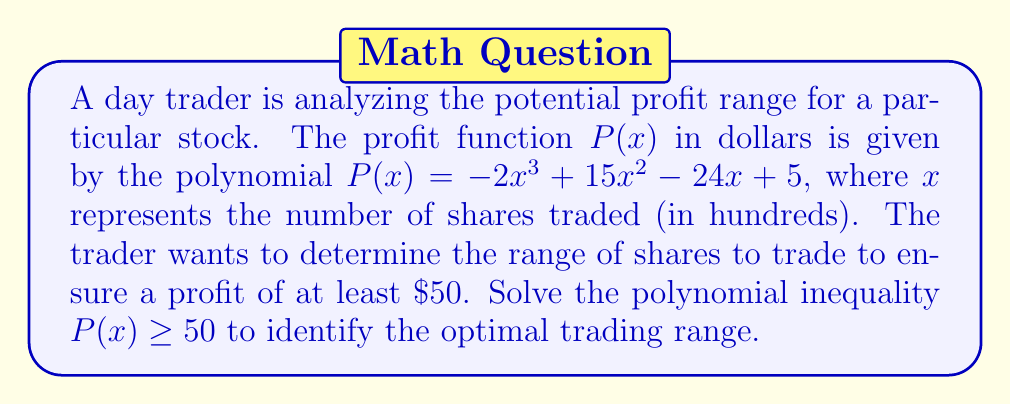Help me with this question. To solve this problem, we need to follow these steps:

1) First, we set up the inequality:
   $$-2x^3 + 15x^2 - 24x + 5 \geq 50$$

2) Subtract 50 from both sides:
   $$-2x^3 + 15x^2 - 24x - 45 \geq 0$$

3) Let's call the left side of the inequality $f(x)$. So we need to solve $f(x) \geq 0$.

4) To find the roots of $f(x)$, we can factor it:
   $$f(x) = -2x^3 + 15x^2 - 24x - 45$$
   $$= -(2x^3 - 15x^2 + 24x + 45)$$
   $$= -(x + 3)(2x^2 - 21x + 15)$$
   $$= -(x + 3)(2x - 3)(x - 9)$$

5) The roots of $f(x)$ are $x = -3$, $x = \frac{3}{2}$, and $x = 9$.

6) Now we need to determine where $f(x) \geq 0$. Since the leading coefficient is negative, $f(x)$ will be positive between its first and second roots, and after its third root.

7) However, since $x$ represents the number of shares traded, it can't be negative. So we only consider the non-negative range.

8) Therefore, the solution to the inequality is:
   $$\frac{3}{2} \leq x \leq 9 \text{ or } x \geq 9$$

9) Converting back to hundreds of shares:
   $$150 \leq x \leq 900 \text{ or } x \geq 900$$
Answer: The optimal trading range for a profit of at least $\$50$ is to trade 150 shares or more. Specifically, trading between 150 and 900 shares (inclusive) or 900 or more shares will yield a profit of at least $\$50$. 